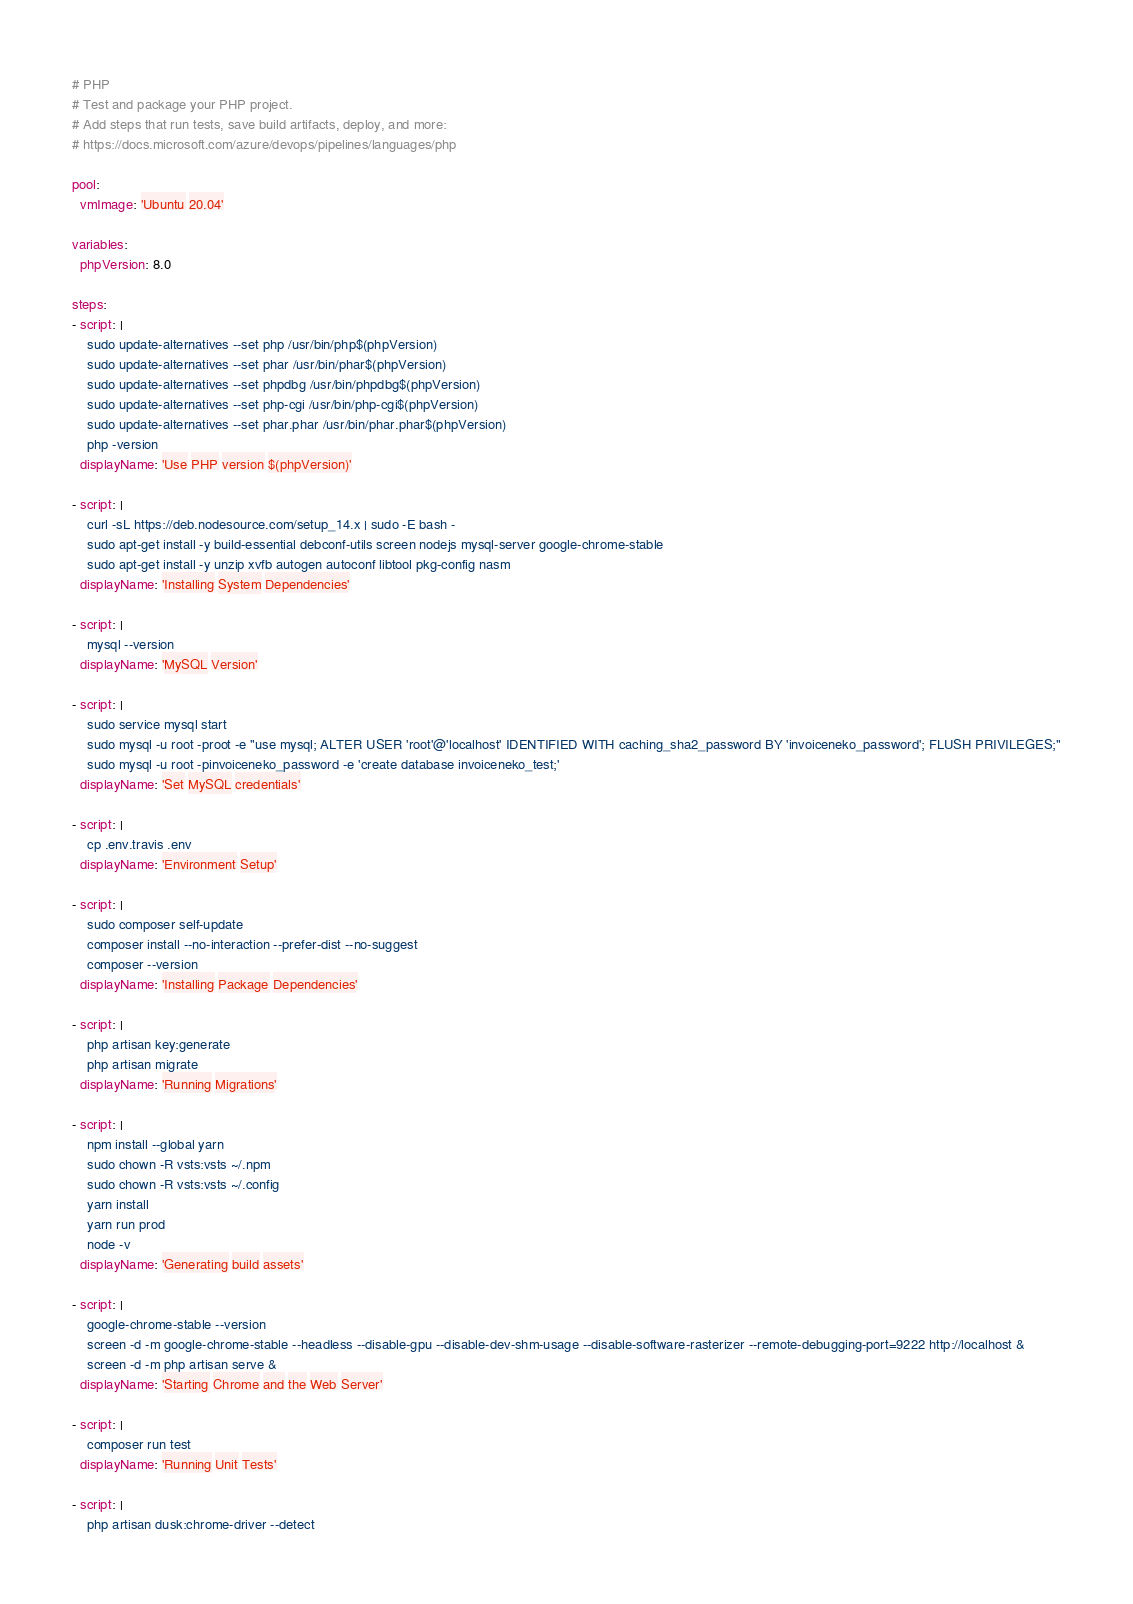<code> <loc_0><loc_0><loc_500><loc_500><_YAML_># PHP
# Test and package your PHP project.
# Add steps that run tests, save build artifacts, deploy, and more:
# https://docs.microsoft.com/azure/devops/pipelines/languages/php

pool:
  vmImage: 'Ubuntu 20.04'

variables:
  phpVersion: 8.0

steps:
- script: |
    sudo update-alternatives --set php /usr/bin/php$(phpVersion)
    sudo update-alternatives --set phar /usr/bin/phar$(phpVersion)
    sudo update-alternatives --set phpdbg /usr/bin/phpdbg$(phpVersion)
    sudo update-alternatives --set php-cgi /usr/bin/php-cgi$(phpVersion)
    sudo update-alternatives --set phar.phar /usr/bin/phar.phar$(phpVersion)
    php -version
  displayName: 'Use PHP version $(phpVersion)'

- script: |
    curl -sL https://deb.nodesource.com/setup_14.x | sudo -E bash -
    sudo apt-get install -y build-essential debconf-utils screen nodejs mysql-server google-chrome-stable
    sudo apt-get install -y unzip xvfb autogen autoconf libtool pkg-config nasm
  displayName: 'Installing System Dependencies'

- script: |
    mysql --version
  displayName: 'MySQL Version'

- script: |
    sudo service mysql start
    sudo mysql -u root -proot -e "use mysql; ALTER USER 'root'@'localhost' IDENTIFIED WITH caching_sha2_password BY 'invoiceneko_password'; FLUSH PRIVILEGES;"
    sudo mysql -u root -pinvoiceneko_password -e 'create database invoiceneko_test;'
  displayName: 'Set MySQL credentials'

- script: |
    cp .env.travis .env
  displayName: 'Environment Setup'

- script: |
    sudo composer self-update
    composer install --no-interaction --prefer-dist --no-suggest
    composer --version
  displayName: 'Installing Package Dependencies'

- script: |
    php artisan key:generate
    php artisan migrate
  displayName: 'Running Migrations'

- script: |
    npm install --global yarn
    sudo chown -R vsts:vsts ~/.npm
    sudo chown -R vsts:vsts ~/.config
    yarn install
    yarn run prod
    node -v
  displayName: 'Generating build assets'

- script: |
    google-chrome-stable --version
    screen -d -m google-chrome-stable --headless --disable-gpu --disable-dev-shm-usage --disable-software-rasterizer --remote-debugging-port=9222 http://localhost &
    screen -d -m php artisan serve &
  displayName: 'Starting Chrome and the Web Server'

- script: |
    composer run test
  displayName: 'Running Unit Tests'

- script: |
    php artisan dusk:chrome-driver --detect</code> 